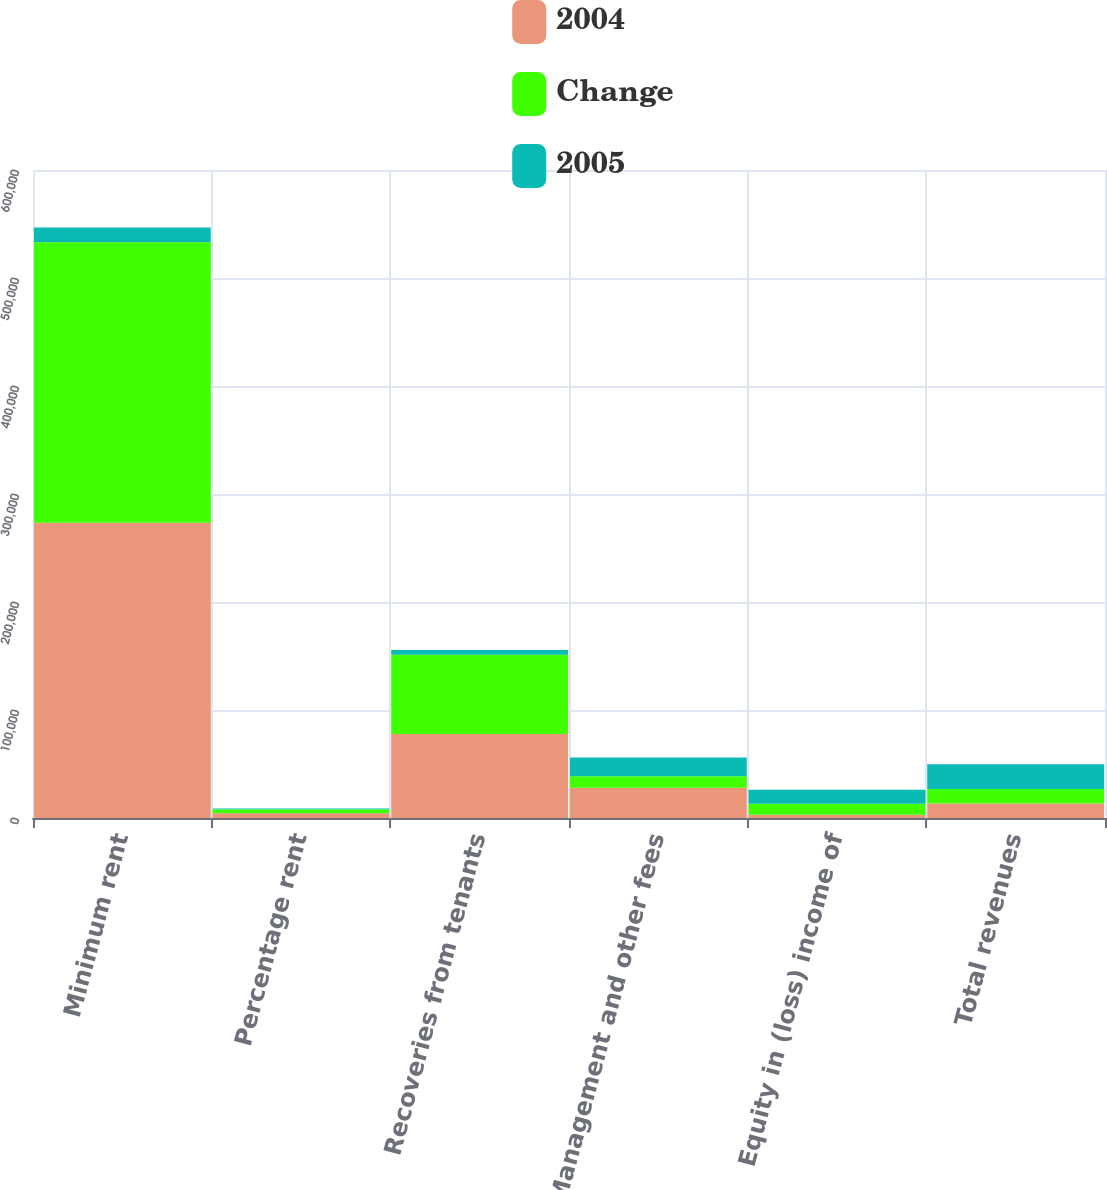Convert chart. <chart><loc_0><loc_0><loc_500><loc_500><stacked_bar_chart><ecel><fcel>Minimum rent<fcel>Percentage rent<fcel>Recoveries from tenants<fcel>Management and other fees<fcel>Equity in (loss) income of<fcel>Total revenues<nl><fcel>2004<fcel>273405<fcel>4364<fcel>77756<fcel>28019<fcel>2908<fcel>13411.5<nl><fcel>Change<fcel>259684<fcel>3738<fcel>73362<fcel>10663<fcel>10194<fcel>13411.5<nl><fcel>2005<fcel>13721<fcel>626<fcel>4394<fcel>17356<fcel>13102<fcel>22995<nl></chart> 